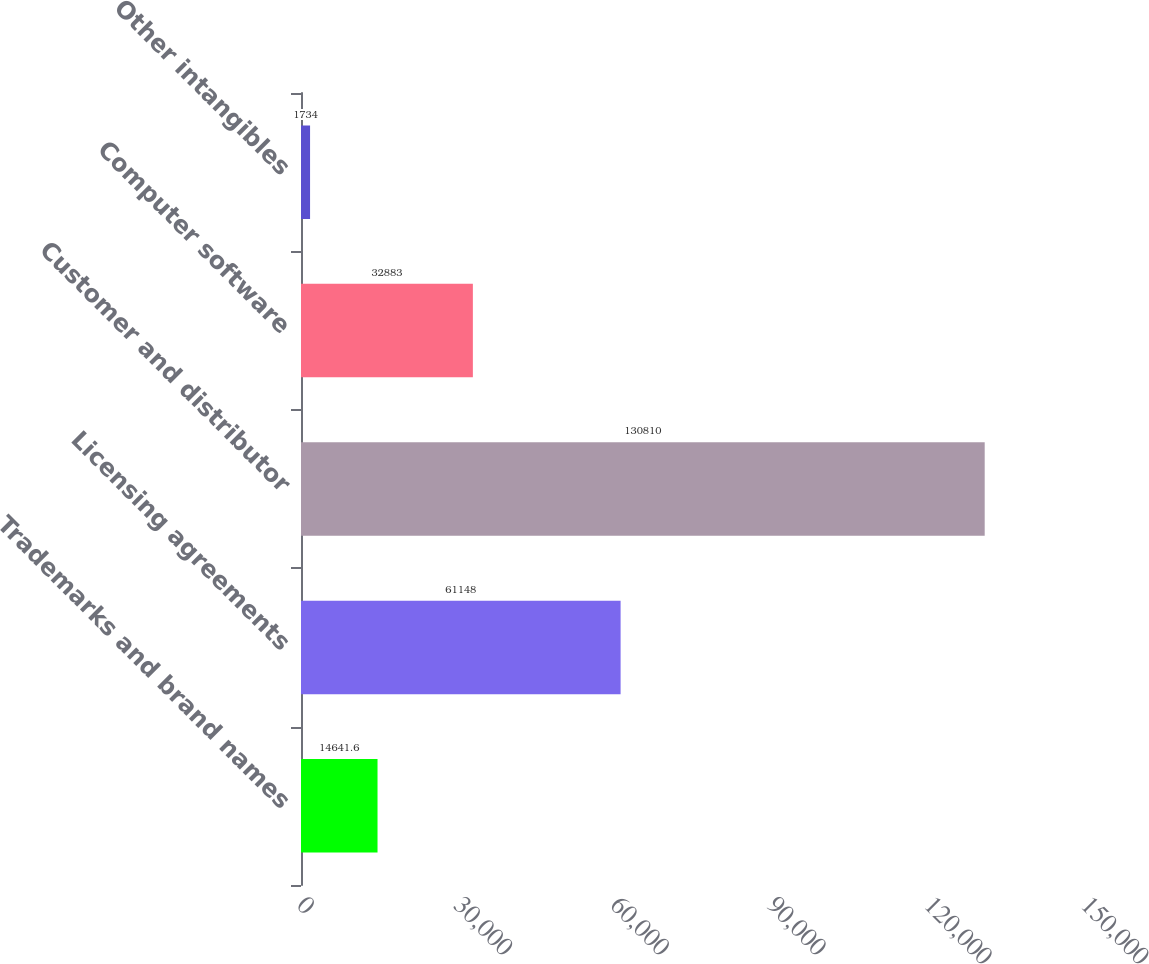Convert chart. <chart><loc_0><loc_0><loc_500><loc_500><bar_chart><fcel>Trademarks and brand names<fcel>Licensing agreements<fcel>Customer and distributor<fcel>Computer software<fcel>Other intangibles<nl><fcel>14641.6<fcel>61148<fcel>130810<fcel>32883<fcel>1734<nl></chart> 